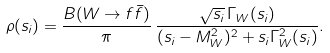Convert formula to latex. <formula><loc_0><loc_0><loc_500><loc_500>\rho ( s _ { i } ) = \frac { B ( W \rightarrow f \bar { f } ) } { \pi } \, \frac { \sqrt { s _ { i } } \, \Gamma _ { W } ( s _ { i } ) } { ( s _ { i } - M ^ { 2 } _ { W } ) ^ { 2 } + s _ { i } \Gamma ^ { 2 } _ { W } ( s _ { i } ) } .</formula> 